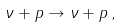Convert formula to latex. <formula><loc_0><loc_0><loc_500><loc_500>\nu + p \rightarrow \nu + p \, ,</formula> 